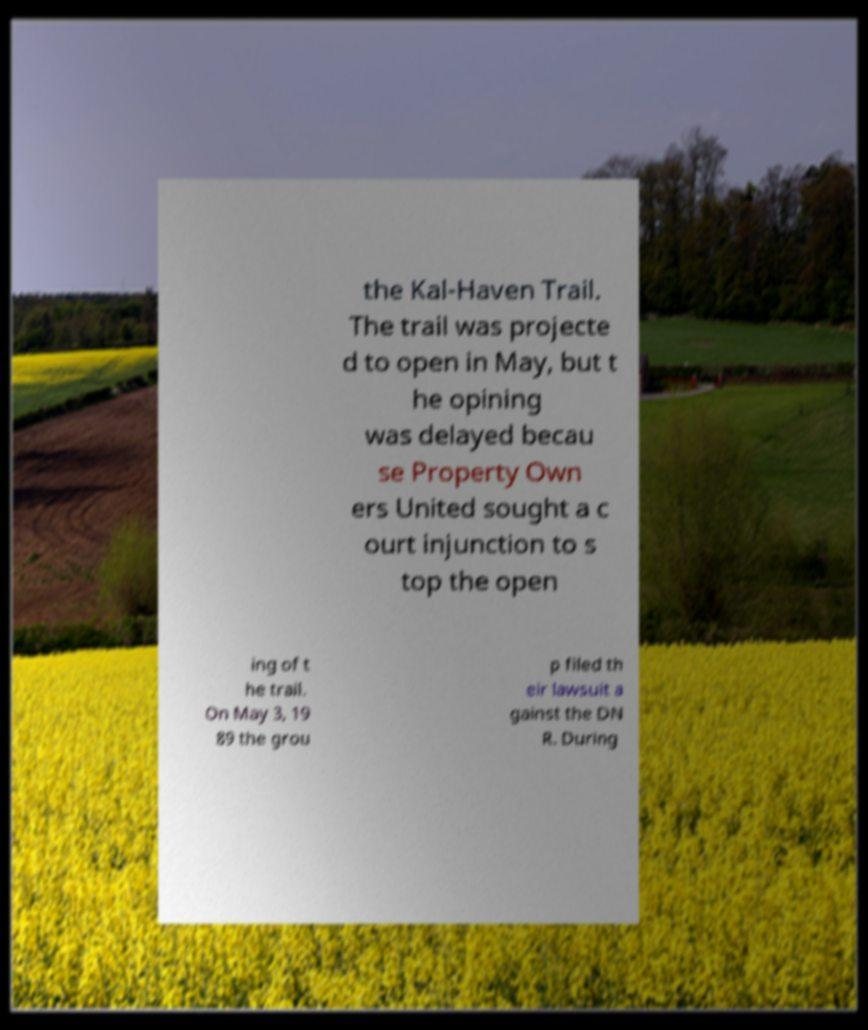I need the written content from this picture converted into text. Can you do that? the Kal-Haven Trail. The trail was projecte d to open in May, but t he opining was delayed becau se Property Own ers United sought a c ourt injunction to s top the open ing of t he trail. On May 3, 19 89 the grou p filed th eir lawsuit a gainst the DN R. During 